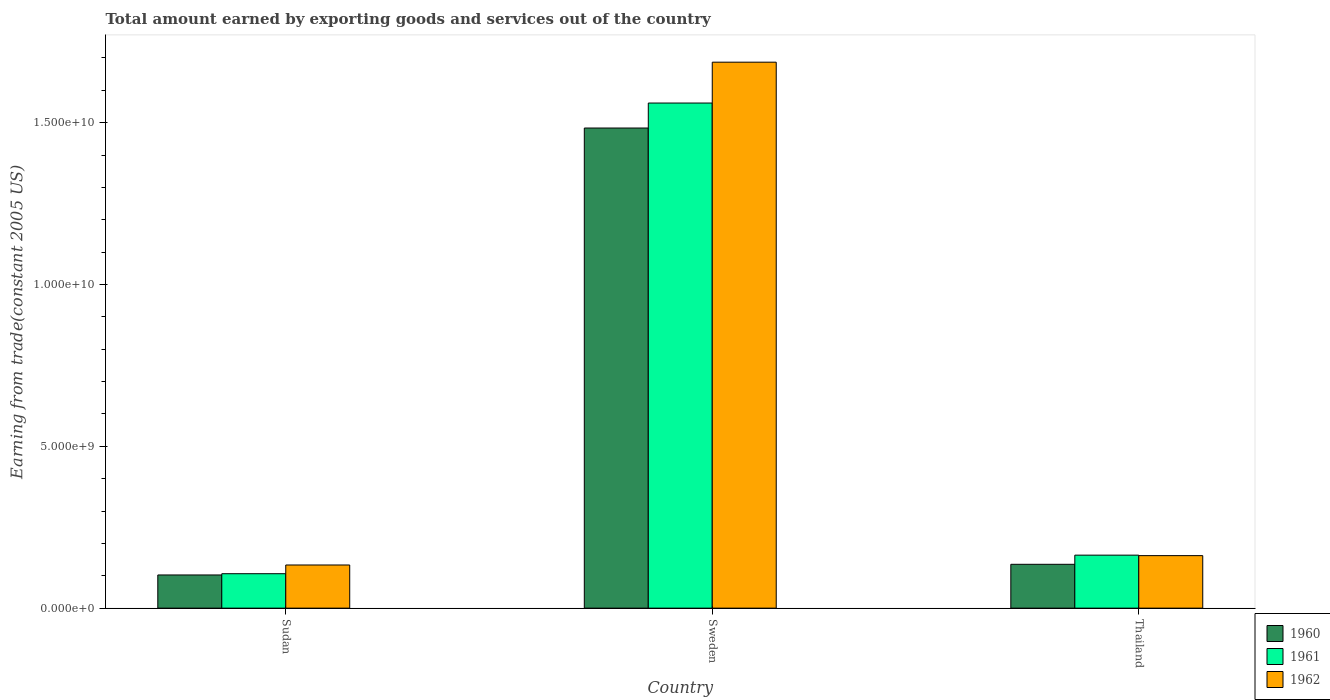How many different coloured bars are there?
Provide a short and direct response. 3. How many groups of bars are there?
Offer a terse response. 3. Are the number of bars per tick equal to the number of legend labels?
Provide a short and direct response. Yes. Are the number of bars on each tick of the X-axis equal?
Make the answer very short. Yes. How many bars are there on the 2nd tick from the left?
Ensure brevity in your answer.  3. How many bars are there on the 1st tick from the right?
Your response must be concise. 3. What is the label of the 3rd group of bars from the left?
Your answer should be very brief. Thailand. In how many cases, is the number of bars for a given country not equal to the number of legend labels?
Make the answer very short. 0. What is the total amount earned by exporting goods and services in 1962 in Sudan?
Your response must be concise. 1.33e+09. Across all countries, what is the maximum total amount earned by exporting goods and services in 1960?
Provide a short and direct response. 1.48e+1. Across all countries, what is the minimum total amount earned by exporting goods and services in 1960?
Keep it short and to the point. 1.03e+09. In which country was the total amount earned by exporting goods and services in 1962 maximum?
Offer a terse response. Sweden. In which country was the total amount earned by exporting goods and services in 1960 minimum?
Ensure brevity in your answer.  Sudan. What is the total total amount earned by exporting goods and services in 1960 in the graph?
Provide a short and direct response. 1.72e+1. What is the difference between the total amount earned by exporting goods and services in 1961 in Sudan and that in Thailand?
Ensure brevity in your answer.  -5.74e+08. What is the difference between the total amount earned by exporting goods and services in 1961 in Thailand and the total amount earned by exporting goods and services in 1962 in Sudan?
Your response must be concise. 3.04e+08. What is the average total amount earned by exporting goods and services in 1961 per country?
Provide a succinct answer. 6.10e+09. What is the difference between the total amount earned by exporting goods and services of/in 1960 and total amount earned by exporting goods and services of/in 1961 in Sudan?
Give a very brief answer. -3.85e+07. In how many countries, is the total amount earned by exporting goods and services in 1962 greater than 4000000000 US$?
Provide a short and direct response. 1. What is the ratio of the total amount earned by exporting goods and services in 1960 in Sweden to that in Thailand?
Your answer should be compact. 10.95. Is the difference between the total amount earned by exporting goods and services in 1960 in Sudan and Thailand greater than the difference between the total amount earned by exporting goods and services in 1961 in Sudan and Thailand?
Offer a very short reply. Yes. What is the difference between the highest and the second highest total amount earned by exporting goods and services in 1960?
Provide a short and direct response. -3.29e+08. What is the difference between the highest and the lowest total amount earned by exporting goods and services in 1962?
Ensure brevity in your answer.  1.55e+1. Is the sum of the total amount earned by exporting goods and services in 1961 in Sudan and Sweden greater than the maximum total amount earned by exporting goods and services in 1960 across all countries?
Your response must be concise. Yes. Is it the case that in every country, the sum of the total amount earned by exporting goods and services in 1960 and total amount earned by exporting goods and services in 1962 is greater than the total amount earned by exporting goods and services in 1961?
Ensure brevity in your answer.  Yes. Are the values on the major ticks of Y-axis written in scientific E-notation?
Your answer should be very brief. Yes. How are the legend labels stacked?
Your response must be concise. Vertical. What is the title of the graph?
Give a very brief answer. Total amount earned by exporting goods and services out of the country. What is the label or title of the Y-axis?
Provide a succinct answer. Earning from trade(constant 2005 US). What is the Earning from trade(constant 2005 US) in 1960 in Sudan?
Your answer should be very brief. 1.03e+09. What is the Earning from trade(constant 2005 US) of 1961 in Sudan?
Your answer should be compact. 1.06e+09. What is the Earning from trade(constant 2005 US) of 1962 in Sudan?
Your response must be concise. 1.33e+09. What is the Earning from trade(constant 2005 US) of 1960 in Sweden?
Give a very brief answer. 1.48e+1. What is the Earning from trade(constant 2005 US) in 1961 in Sweden?
Offer a terse response. 1.56e+1. What is the Earning from trade(constant 2005 US) in 1962 in Sweden?
Keep it short and to the point. 1.69e+1. What is the Earning from trade(constant 2005 US) of 1960 in Thailand?
Your answer should be very brief. 1.35e+09. What is the Earning from trade(constant 2005 US) in 1961 in Thailand?
Provide a succinct answer. 1.64e+09. What is the Earning from trade(constant 2005 US) of 1962 in Thailand?
Your answer should be very brief. 1.62e+09. Across all countries, what is the maximum Earning from trade(constant 2005 US) of 1960?
Provide a short and direct response. 1.48e+1. Across all countries, what is the maximum Earning from trade(constant 2005 US) in 1961?
Give a very brief answer. 1.56e+1. Across all countries, what is the maximum Earning from trade(constant 2005 US) of 1962?
Your answer should be compact. 1.69e+1. Across all countries, what is the minimum Earning from trade(constant 2005 US) in 1960?
Provide a succinct answer. 1.03e+09. Across all countries, what is the minimum Earning from trade(constant 2005 US) of 1961?
Keep it short and to the point. 1.06e+09. Across all countries, what is the minimum Earning from trade(constant 2005 US) in 1962?
Offer a terse response. 1.33e+09. What is the total Earning from trade(constant 2005 US) of 1960 in the graph?
Offer a terse response. 1.72e+1. What is the total Earning from trade(constant 2005 US) in 1961 in the graph?
Provide a succinct answer. 1.83e+1. What is the total Earning from trade(constant 2005 US) of 1962 in the graph?
Your response must be concise. 1.98e+1. What is the difference between the Earning from trade(constant 2005 US) of 1960 in Sudan and that in Sweden?
Ensure brevity in your answer.  -1.38e+1. What is the difference between the Earning from trade(constant 2005 US) of 1961 in Sudan and that in Sweden?
Offer a terse response. -1.45e+1. What is the difference between the Earning from trade(constant 2005 US) in 1962 in Sudan and that in Sweden?
Your response must be concise. -1.55e+1. What is the difference between the Earning from trade(constant 2005 US) in 1960 in Sudan and that in Thailand?
Offer a terse response. -3.29e+08. What is the difference between the Earning from trade(constant 2005 US) in 1961 in Sudan and that in Thailand?
Your response must be concise. -5.74e+08. What is the difference between the Earning from trade(constant 2005 US) of 1962 in Sudan and that in Thailand?
Offer a very short reply. -2.89e+08. What is the difference between the Earning from trade(constant 2005 US) in 1960 in Sweden and that in Thailand?
Your answer should be compact. 1.35e+1. What is the difference between the Earning from trade(constant 2005 US) in 1961 in Sweden and that in Thailand?
Provide a short and direct response. 1.40e+1. What is the difference between the Earning from trade(constant 2005 US) in 1962 in Sweden and that in Thailand?
Offer a terse response. 1.52e+1. What is the difference between the Earning from trade(constant 2005 US) in 1960 in Sudan and the Earning from trade(constant 2005 US) in 1961 in Sweden?
Give a very brief answer. -1.46e+1. What is the difference between the Earning from trade(constant 2005 US) in 1960 in Sudan and the Earning from trade(constant 2005 US) in 1962 in Sweden?
Give a very brief answer. -1.58e+1. What is the difference between the Earning from trade(constant 2005 US) of 1961 in Sudan and the Earning from trade(constant 2005 US) of 1962 in Sweden?
Offer a very short reply. -1.58e+1. What is the difference between the Earning from trade(constant 2005 US) of 1960 in Sudan and the Earning from trade(constant 2005 US) of 1961 in Thailand?
Keep it short and to the point. -6.12e+08. What is the difference between the Earning from trade(constant 2005 US) of 1960 in Sudan and the Earning from trade(constant 2005 US) of 1962 in Thailand?
Make the answer very short. -5.97e+08. What is the difference between the Earning from trade(constant 2005 US) in 1961 in Sudan and the Earning from trade(constant 2005 US) in 1962 in Thailand?
Offer a very short reply. -5.59e+08. What is the difference between the Earning from trade(constant 2005 US) in 1960 in Sweden and the Earning from trade(constant 2005 US) in 1961 in Thailand?
Make the answer very short. 1.32e+1. What is the difference between the Earning from trade(constant 2005 US) of 1960 in Sweden and the Earning from trade(constant 2005 US) of 1962 in Thailand?
Offer a terse response. 1.32e+1. What is the difference between the Earning from trade(constant 2005 US) in 1961 in Sweden and the Earning from trade(constant 2005 US) in 1962 in Thailand?
Keep it short and to the point. 1.40e+1. What is the average Earning from trade(constant 2005 US) in 1960 per country?
Offer a very short reply. 5.74e+09. What is the average Earning from trade(constant 2005 US) of 1961 per country?
Your answer should be compact. 6.10e+09. What is the average Earning from trade(constant 2005 US) of 1962 per country?
Offer a very short reply. 6.61e+09. What is the difference between the Earning from trade(constant 2005 US) of 1960 and Earning from trade(constant 2005 US) of 1961 in Sudan?
Your response must be concise. -3.85e+07. What is the difference between the Earning from trade(constant 2005 US) of 1960 and Earning from trade(constant 2005 US) of 1962 in Sudan?
Your answer should be compact. -3.08e+08. What is the difference between the Earning from trade(constant 2005 US) of 1961 and Earning from trade(constant 2005 US) of 1962 in Sudan?
Give a very brief answer. -2.69e+08. What is the difference between the Earning from trade(constant 2005 US) in 1960 and Earning from trade(constant 2005 US) in 1961 in Sweden?
Your answer should be compact. -7.72e+08. What is the difference between the Earning from trade(constant 2005 US) of 1960 and Earning from trade(constant 2005 US) of 1962 in Sweden?
Make the answer very short. -2.03e+09. What is the difference between the Earning from trade(constant 2005 US) in 1961 and Earning from trade(constant 2005 US) in 1962 in Sweden?
Your answer should be compact. -1.26e+09. What is the difference between the Earning from trade(constant 2005 US) of 1960 and Earning from trade(constant 2005 US) of 1961 in Thailand?
Your answer should be compact. -2.83e+08. What is the difference between the Earning from trade(constant 2005 US) of 1960 and Earning from trade(constant 2005 US) of 1962 in Thailand?
Your answer should be compact. -2.68e+08. What is the difference between the Earning from trade(constant 2005 US) of 1961 and Earning from trade(constant 2005 US) of 1962 in Thailand?
Give a very brief answer. 1.49e+07. What is the ratio of the Earning from trade(constant 2005 US) of 1960 in Sudan to that in Sweden?
Provide a short and direct response. 0.07. What is the ratio of the Earning from trade(constant 2005 US) of 1961 in Sudan to that in Sweden?
Give a very brief answer. 0.07. What is the ratio of the Earning from trade(constant 2005 US) of 1962 in Sudan to that in Sweden?
Your response must be concise. 0.08. What is the ratio of the Earning from trade(constant 2005 US) in 1960 in Sudan to that in Thailand?
Your answer should be very brief. 0.76. What is the ratio of the Earning from trade(constant 2005 US) of 1961 in Sudan to that in Thailand?
Give a very brief answer. 0.65. What is the ratio of the Earning from trade(constant 2005 US) of 1962 in Sudan to that in Thailand?
Your answer should be compact. 0.82. What is the ratio of the Earning from trade(constant 2005 US) in 1960 in Sweden to that in Thailand?
Your answer should be compact. 10.95. What is the ratio of the Earning from trade(constant 2005 US) of 1961 in Sweden to that in Thailand?
Offer a terse response. 9.53. What is the ratio of the Earning from trade(constant 2005 US) in 1962 in Sweden to that in Thailand?
Your answer should be very brief. 10.4. What is the difference between the highest and the second highest Earning from trade(constant 2005 US) in 1960?
Offer a terse response. 1.35e+1. What is the difference between the highest and the second highest Earning from trade(constant 2005 US) of 1961?
Offer a very short reply. 1.40e+1. What is the difference between the highest and the second highest Earning from trade(constant 2005 US) in 1962?
Your answer should be very brief. 1.52e+1. What is the difference between the highest and the lowest Earning from trade(constant 2005 US) of 1960?
Make the answer very short. 1.38e+1. What is the difference between the highest and the lowest Earning from trade(constant 2005 US) in 1961?
Provide a short and direct response. 1.45e+1. What is the difference between the highest and the lowest Earning from trade(constant 2005 US) of 1962?
Offer a terse response. 1.55e+1. 